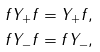Convert formula to latex. <formula><loc_0><loc_0><loc_500><loc_500>f Y _ { + } f & = Y _ { + } f , \\ f Y _ { - } f & = f Y _ { - } ,</formula> 